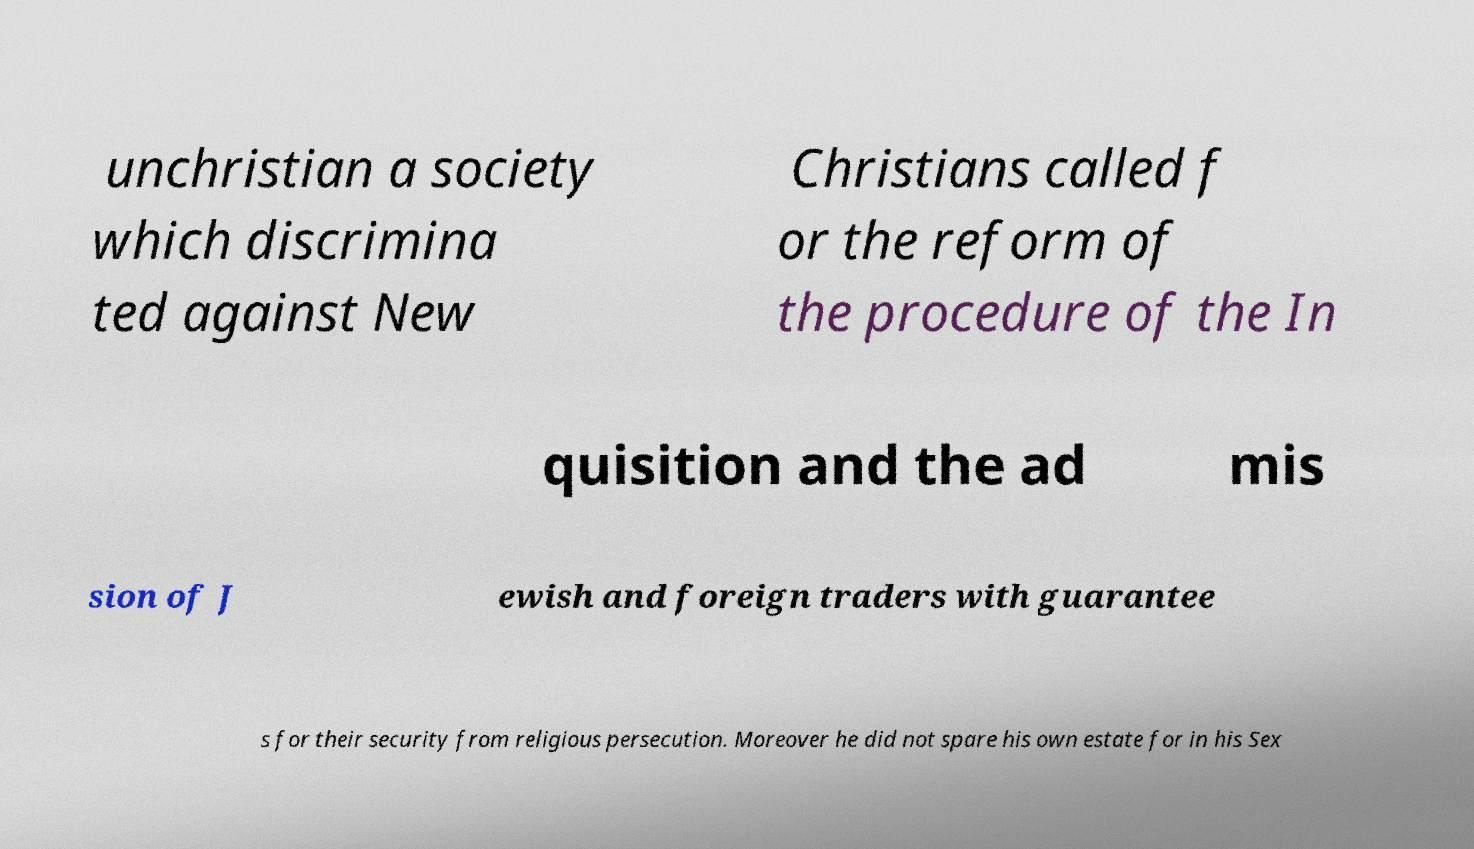For documentation purposes, I need the text within this image transcribed. Could you provide that? unchristian a society which discrimina ted against New Christians called f or the reform of the procedure of the In quisition and the ad mis sion of J ewish and foreign traders with guarantee s for their security from religious persecution. Moreover he did not spare his own estate for in his Sex 